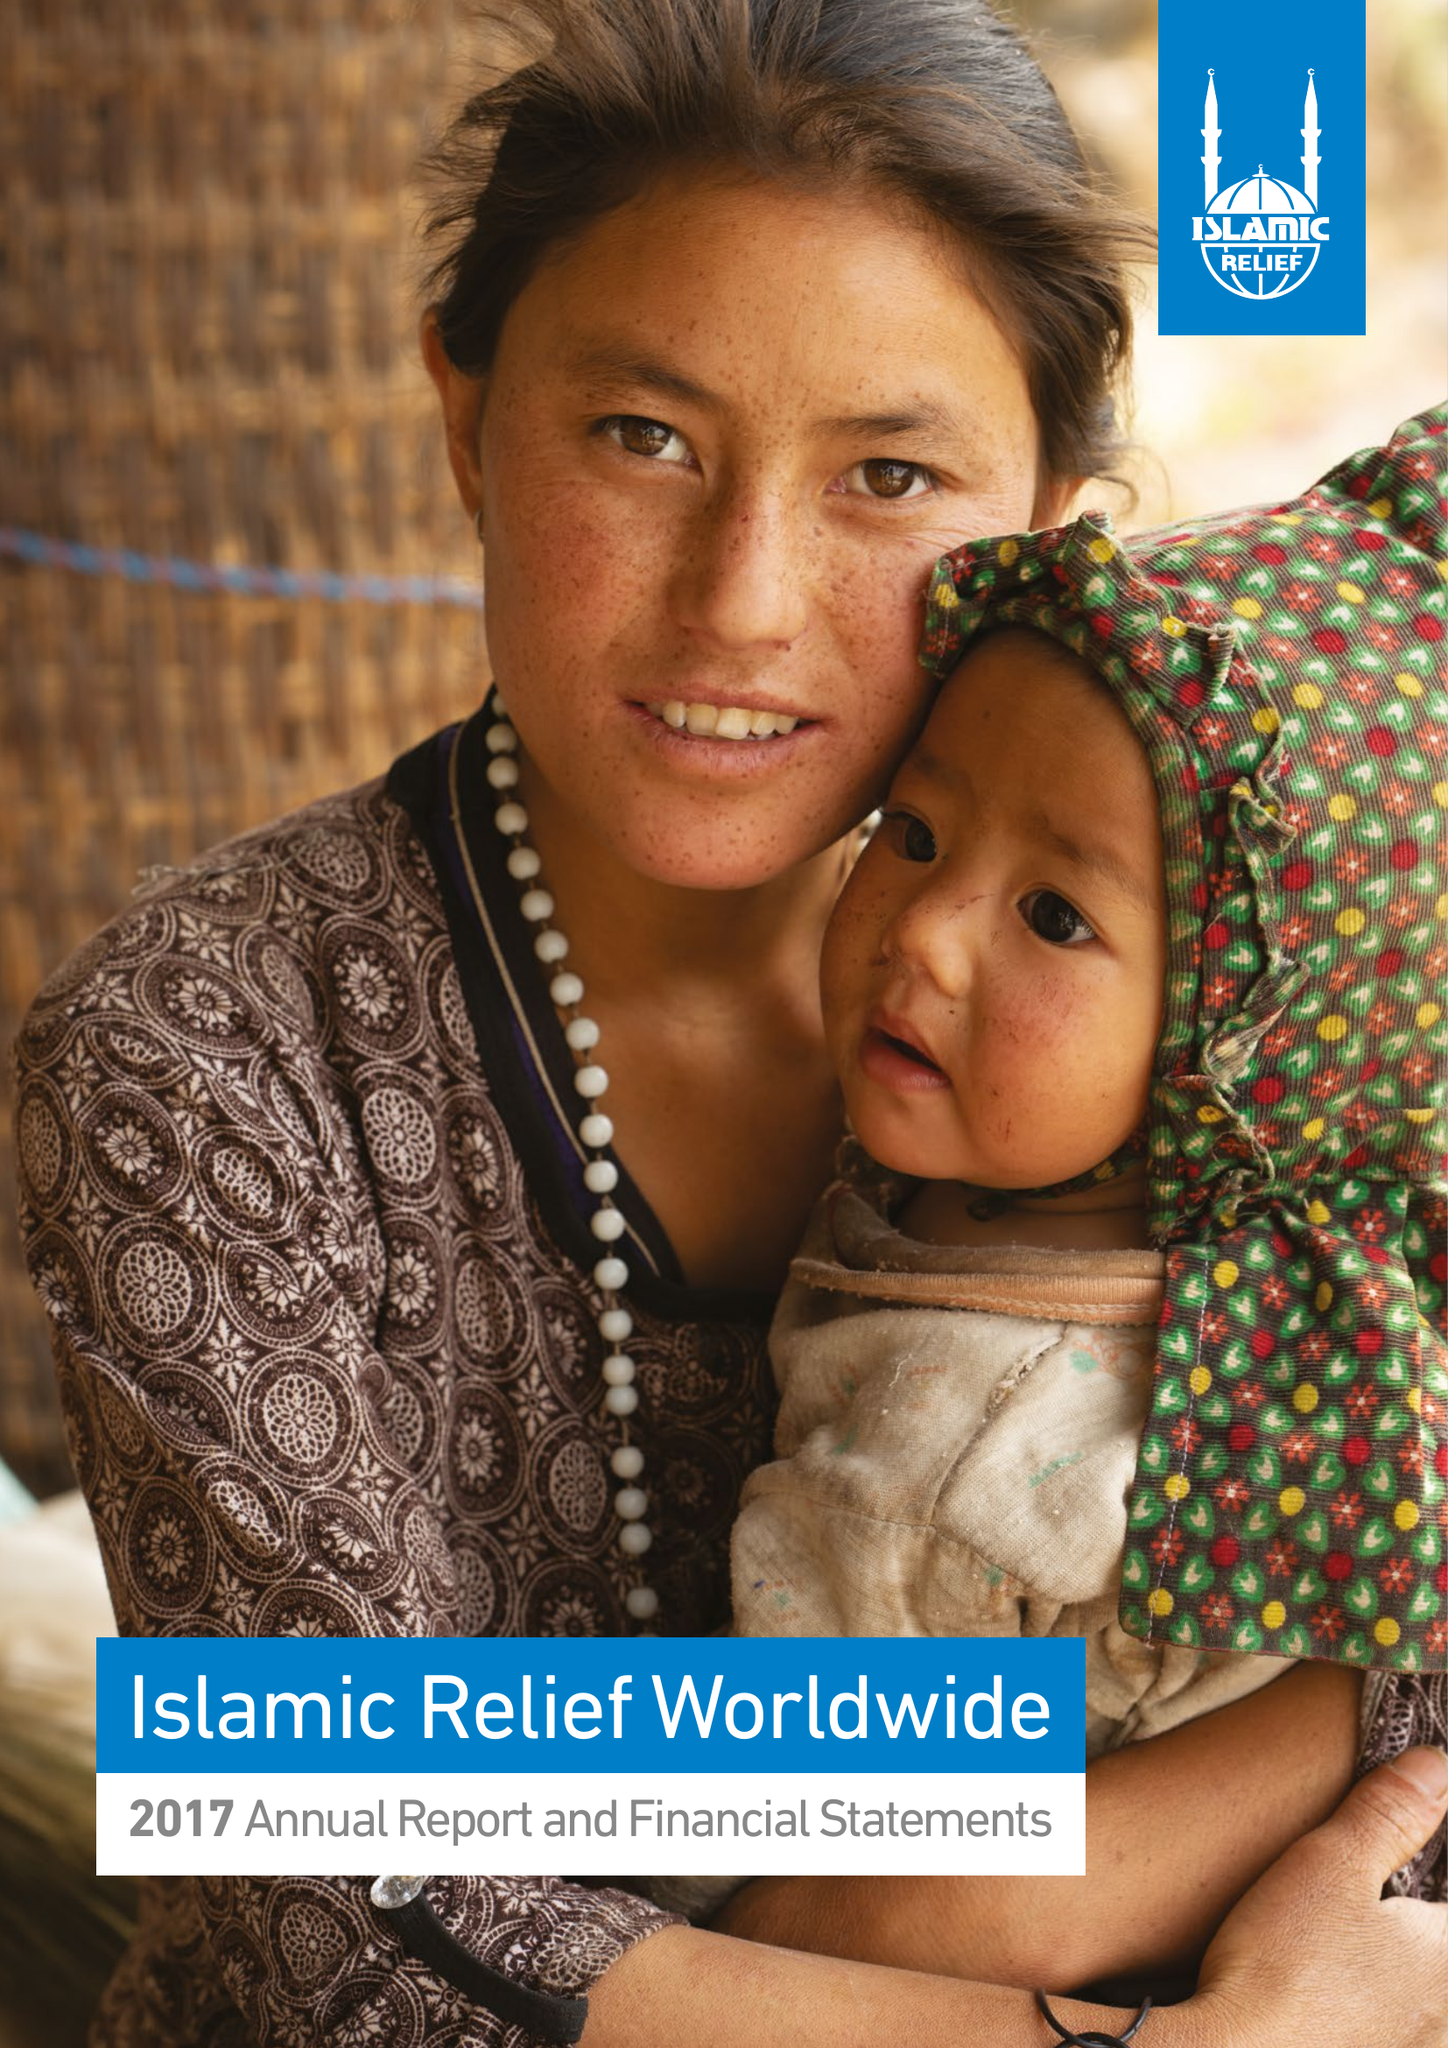What is the value for the address__post_town?
Answer the question using a single word or phrase. BIRMINGHAM 